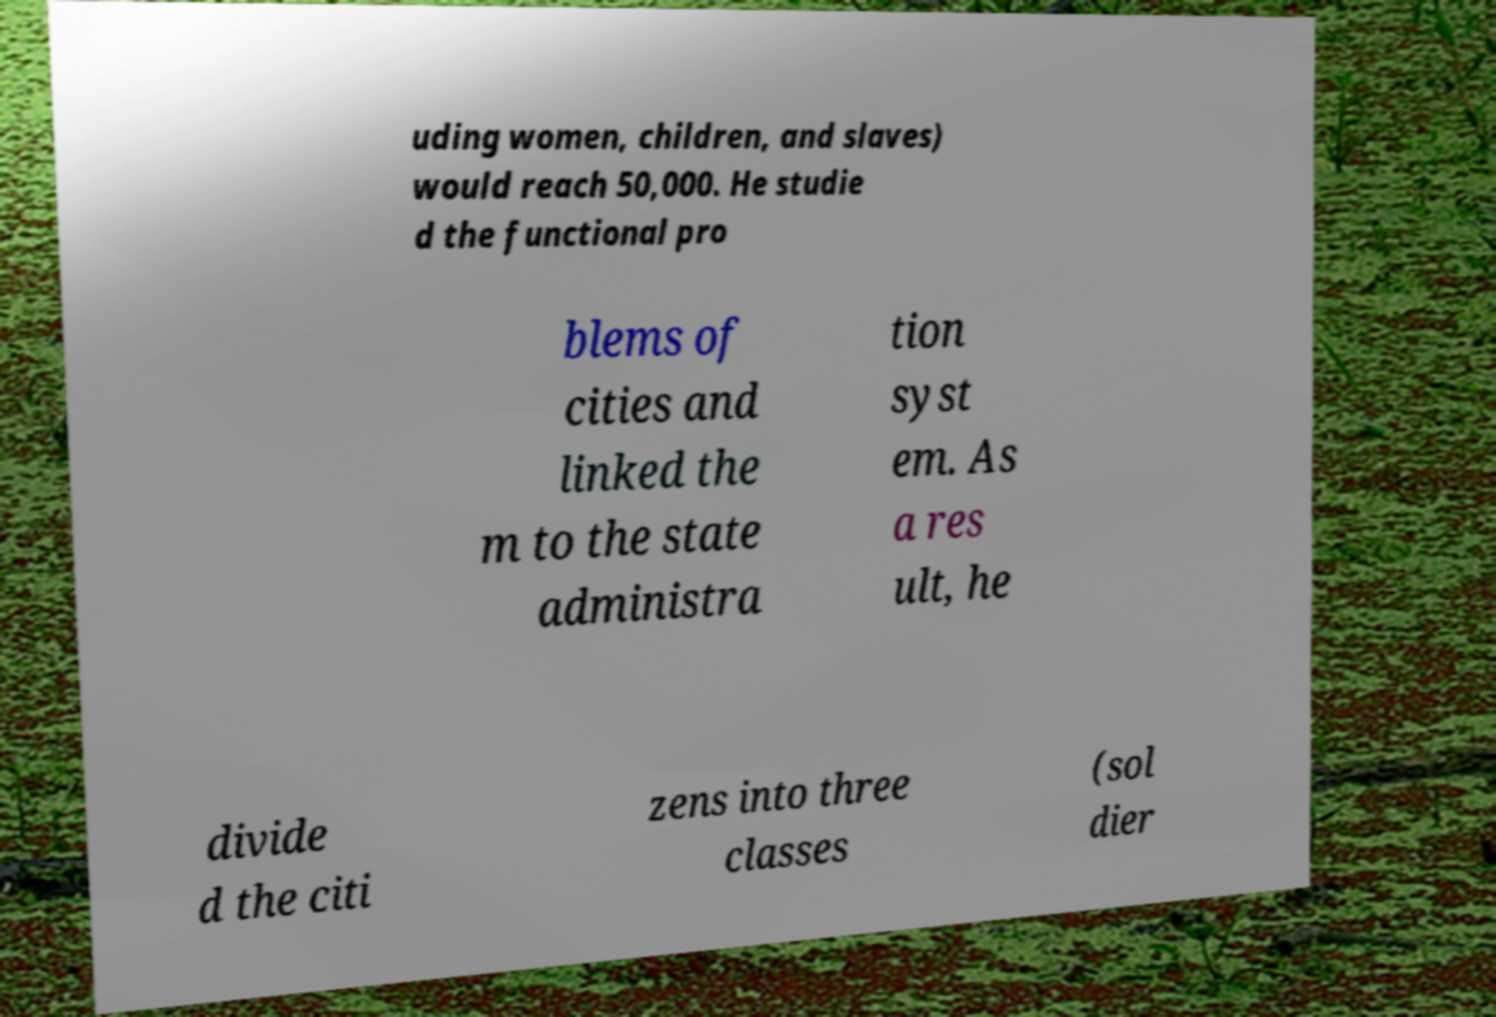For documentation purposes, I need the text within this image transcribed. Could you provide that? uding women, children, and slaves) would reach 50,000. He studie d the functional pro blems of cities and linked the m to the state administra tion syst em. As a res ult, he divide d the citi zens into three classes (sol dier 